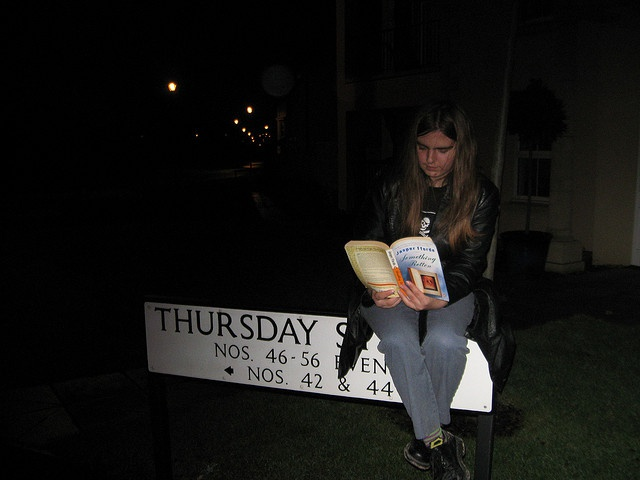Describe the objects in this image and their specific colors. I can see people in black, gray, and maroon tones, book in black, darkgray, tan, and lightgray tones, and potted plant in black tones in this image. 